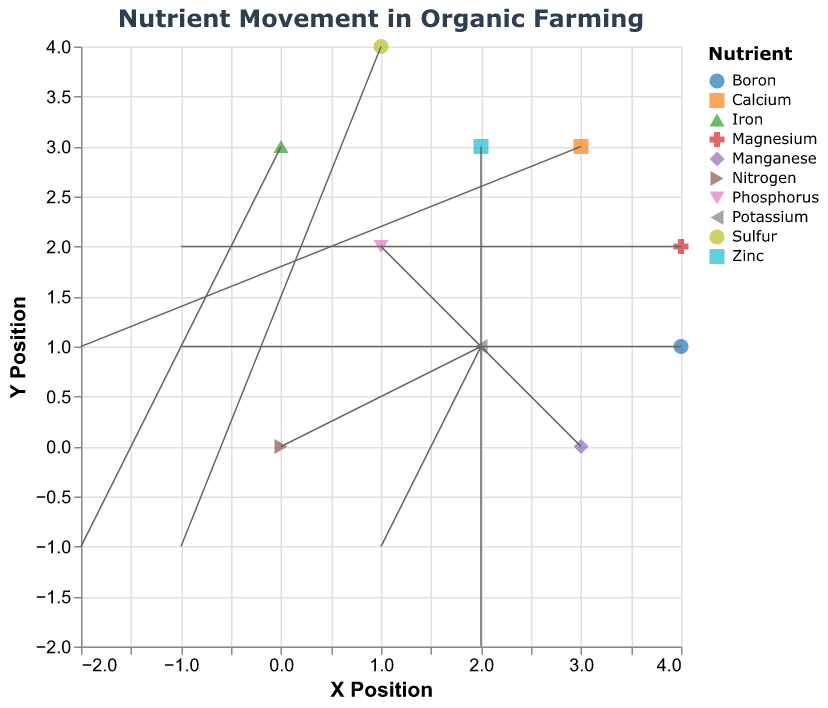What is the title of the plot? The title can be found at the top of the plot.
Answer: Nutrient Movement in Organic Farming How many types of nutrients are represented in the plot? Count the distinct categories in the legend.
Answer: 10 Which nutrient has a movement vector pointing down and to the left (a negative x and negative y direction)? Identify the vector with negative u and negative v values.
Answer: Sulfur What are the x and y coordinates for the Iron vector's starting point? Look for the point labeled "Iron" and check the tooltip or data point.
Answer: (0, 3) Which nutrient has the largest horizontal displacement? Compare the absolute values of the u components across all vectors.
Answer: Zinc Calculate the difference in vertical displacement between Magnesium and Phosphorus vectors. Subtract the v value of Phosphorus from the v value of Magnesium.
Answer: 0 Which nutrient is located at (3, 0) and what is its movement vector? Find the point at (3, 0) and read its vector components.
Answer: Manganese (1, 2) Identify the nutrient with a north-east direction of movement. Look for a vector with both u and v components positive.
Answer: Nitrogen Compare the movement vectors of Potassium and Calcium. Which one has a greater vertical displacement? Check the absolute values of the v components for both nutrients.
Answer: Calcium Which nutrient has a movement vector that remains in the same vertical position but moves horizontally? Identify the vector with a v component of 0.
Answer: None 